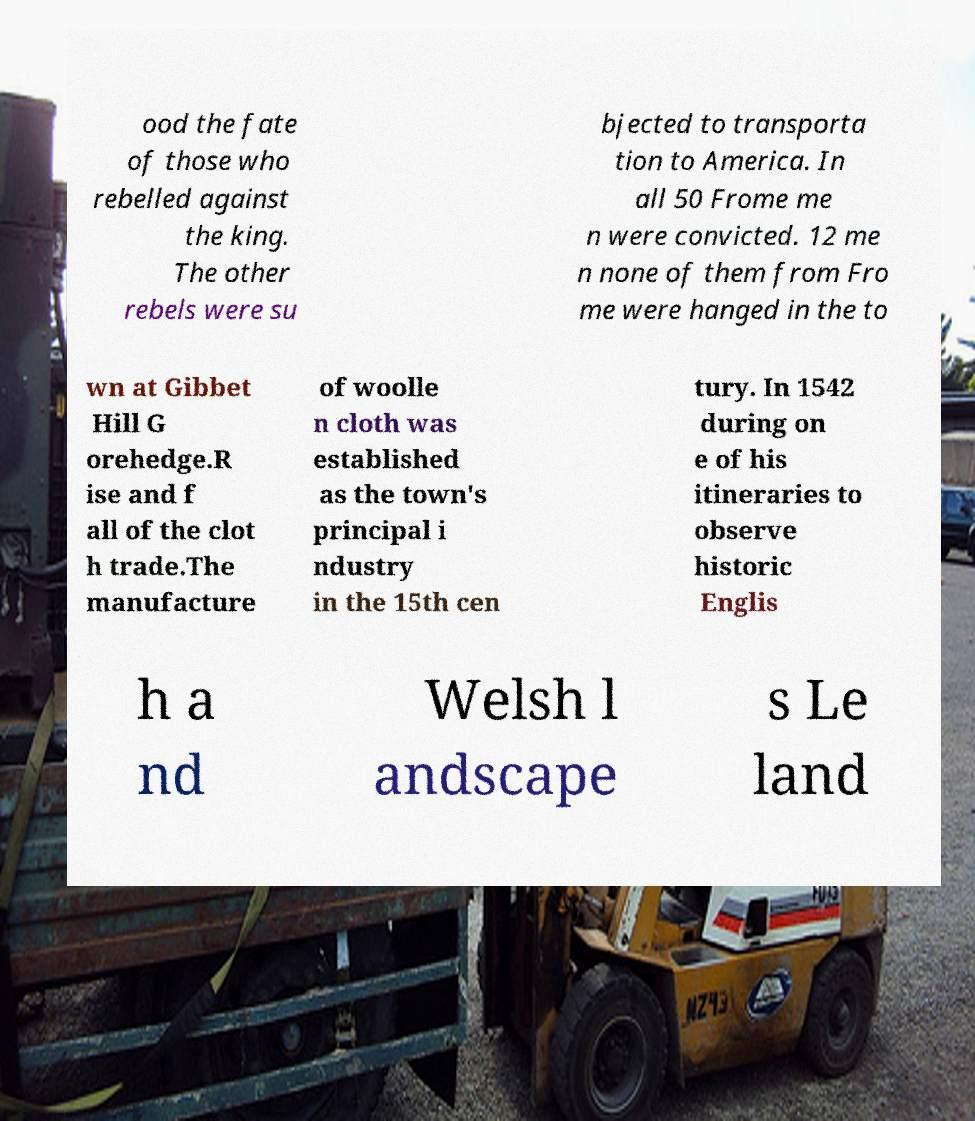What messages or text are displayed in this image? I need them in a readable, typed format. ood the fate of those who rebelled against the king. The other rebels were su bjected to transporta tion to America. In all 50 Frome me n were convicted. 12 me n none of them from Fro me were hanged in the to wn at Gibbet Hill G orehedge.R ise and f all of the clot h trade.The manufacture of woolle n cloth was established as the town's principal i ndustry in the 15th cen tury. In 1542 during on e of his itineraries to observe historic Englis h a nd Welsh l andscape s Le land 